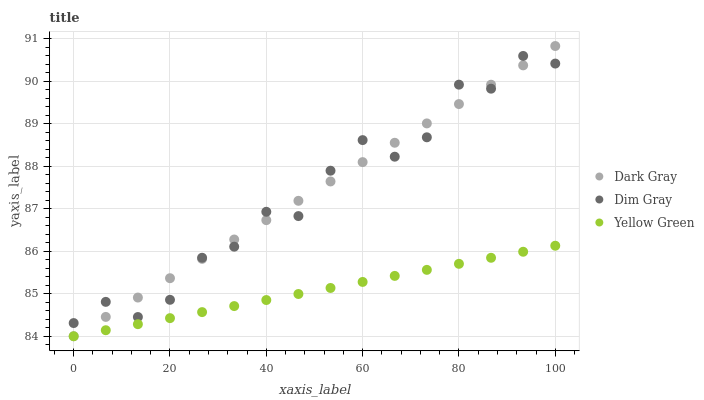Does Yellow Green have the minimum area under the curve?
Answer yes or no. Yes. Does Dark Gray have the maximum area under the curve?
Answer yes or no. Yes. Does Dim Gray have the minimum area under the curve?
Answer yes or no. No. Does Dim Gray have the maximum area under the curve?
Answer yes or no. No. Is Dark Gray the smoothest?
Answer yes or no. Yes. Is Dim Gray the roughest?
Answer yes or no. Yes. Is Yellow Green the smoothest?
Answer yes or no. No. Is Yellow Green the roughest?
Answer yes or no. No. Does Dark Gray have the lowest value?
Answer yes or no. Yes. Does Dim Gray have the lowest value?
Answer yes or no. No. Does Dark Gray have the highest value?
Answer yes or no. Yes. Does Dim Gray have the highest value?
Answer yes or no. No. Is Yellow Green less than Dim Gray?
Answer yes or no. Yes. Is Dim Gray greater than Yellow Green?
Answer yes or no. Yes. Does Yellow Green intersect Dark Gray?
Answer yes or no. Yes. Is Yellow Green less than Dark Gray?
Answer yes or no. No. Is Yellow Green greater than Dark Gray?
Answer yes or no. No. Does Yellow Green intersect Dim Gray?
Answer yes or no. No. 